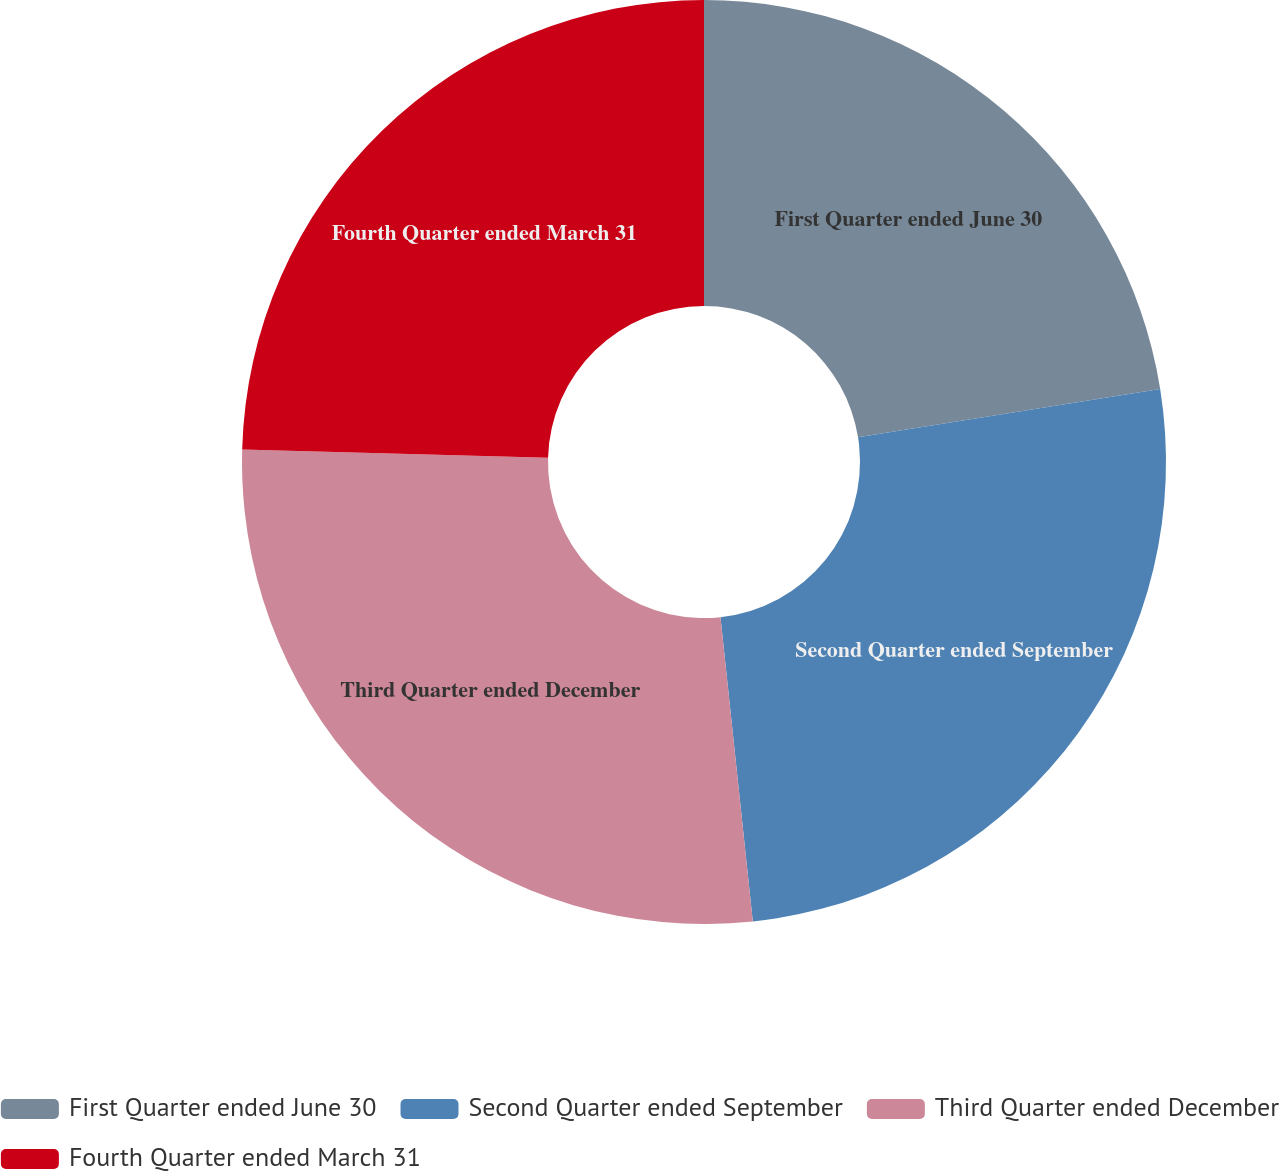Convert chart to OTSL. <chart><loc_0><loc_0><loc_500><loc_500><pie_chart><fcel>First Quarter ended June 30<fcel>Second Quarter ended September<fcel>Third Quarter ended December<fcel>Fourth Quarter ended March 31<nl><fcel>22.47%<fcel>25.84%<fcel>27.11%<fcel>24.57%<nl></chart> 